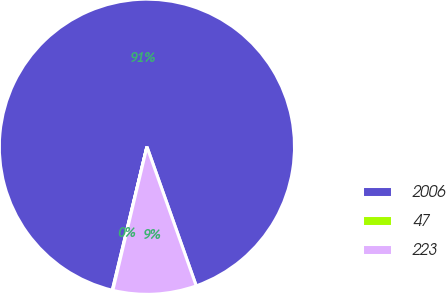Convert chart to OTSL. <chart><loc_0><loc_0><loc_500><loc_500><pie_chart><fcel>2006<fcel>47<fcel>223<nl><fcel>90.81%<fcel>0.06%<fcel>9.13%<nl></chart> 